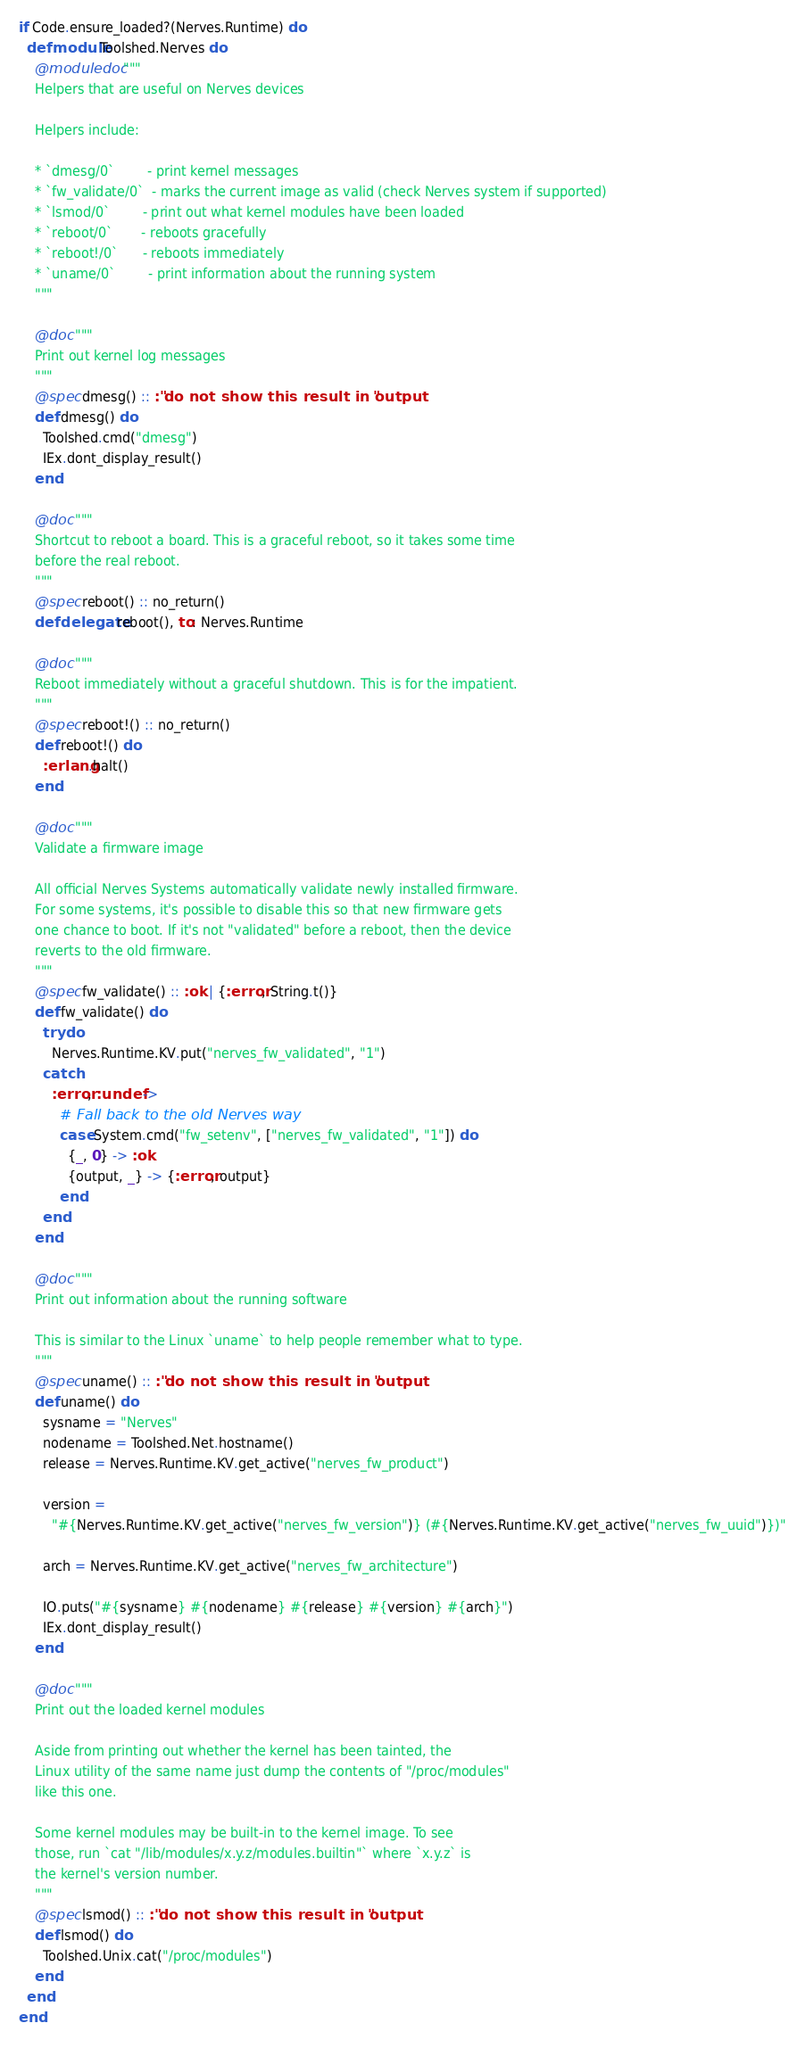Convert code to text. <code><loc_0><loc_0><loc_500><loc_500><_Elixir_>if Code.ensure_loaded?(Nerves.Runtime) do
  defmodule Toolshed.Nerves do
    @moduledoc """
    Helpers that are useful on Nerves devices

    Helpers include:

    * `dmesg/0`        - print kernel messages
    * `fw_validate/0`  - marks the current image as valid (check Nerves system if supported)
    * `lsmod/0`        - print out what kernel modules have been loaded
    * `reboot/0`       - reboots gracefully
    * `reboot!/0`      - reboots immediately
    * `uname/0`        - print information about the running system
    """

    @doc """
    Print out kernel log messages
    """
    @spec dmesg() :: :"do not show this result in output"
    def dmesg() do
      Toolshed.cmd("dmesg")
      IEx.dont_display_result()
    end

    @doc """
    Shortcut to reboot a board. This is a graceful reboot, so it takes some time
    before the real reboot.
    """
    @spec reboot() :: no_return()
    defdelegate reboot(), to: Nerves.Runtime

    @doc """
    Reboot immediately without a graceful shutdown. This is for the impatient.
    """
    @spec reboot!() :: no_return()
    def reboot!() do
      :erlang.halt()
    end

    @doc """
    Validate a firmware image

    All official Nerves Systems automatically validate newly installed firmware.
    For some systems, it's possible to disable this so that new firmware gets
    one chance to boot. If it's not "validated" before a reboot, then the device
    reverts to the old firmware.
    """
    @spec fw_validate() :: :ok | {:error, String.t()}
    def fw_validate() do
      try do
        Nerves.Runtime.KV.put("nerves_fw_validated", "1")
      catch
        :error, :undef ->
          # Fall back to the old Nerves way
          case System.cmd("fw_setenv", ["nerves_fw_validated", "1"]) do
            {_, 0} -> :ok
            {output, _} -> {:error, output}
          end
      end
    end

    @doc """
    Print out information about the running software

    This is similar to the Linux `uname` to help people remember what to type.
    """
    @spec uname() :: :"do not show this result in output"
    def uname() do
      sysname = "Nerves"
      nodename = Toolshed.Net.hostname()
      release = Nerves.Runtime.KV.get_active("nerves_fw_product")

      version =
        "#{Nerves.Runtime.KV.get_active("nerves_fw_version")} (#{Nerves.Runtime.KV.get_active("nerves_fw_uuid")})"

      arch = Nerves.Runtime.KV.get_active("nerves_fw_architecture")

      IO.puts("#{sysname} #{nodename} #{release} #{version} #{arch}")
      IEx.dont_display_result()
    end

    @doc """
    Print out the loaded kernel modules

    Aside from printing out whether the kernel has been tainted, the
    Linux utility of the same name just dump the contents of "/proc/modules"
    like this one.

    Some kernel modules may be built-in to the kernel image. To see
    those, run `cat "/lib/modules/x.y.z/modules.builtin"` where `x.y.z` is
    the kernel's version number.
    """
    @spec lsmod() :: :"do not show this result in output"
    def lsmod() do
      Toolshed.Unix.cat("/proc/modules")
    end
  end
end
</code> 